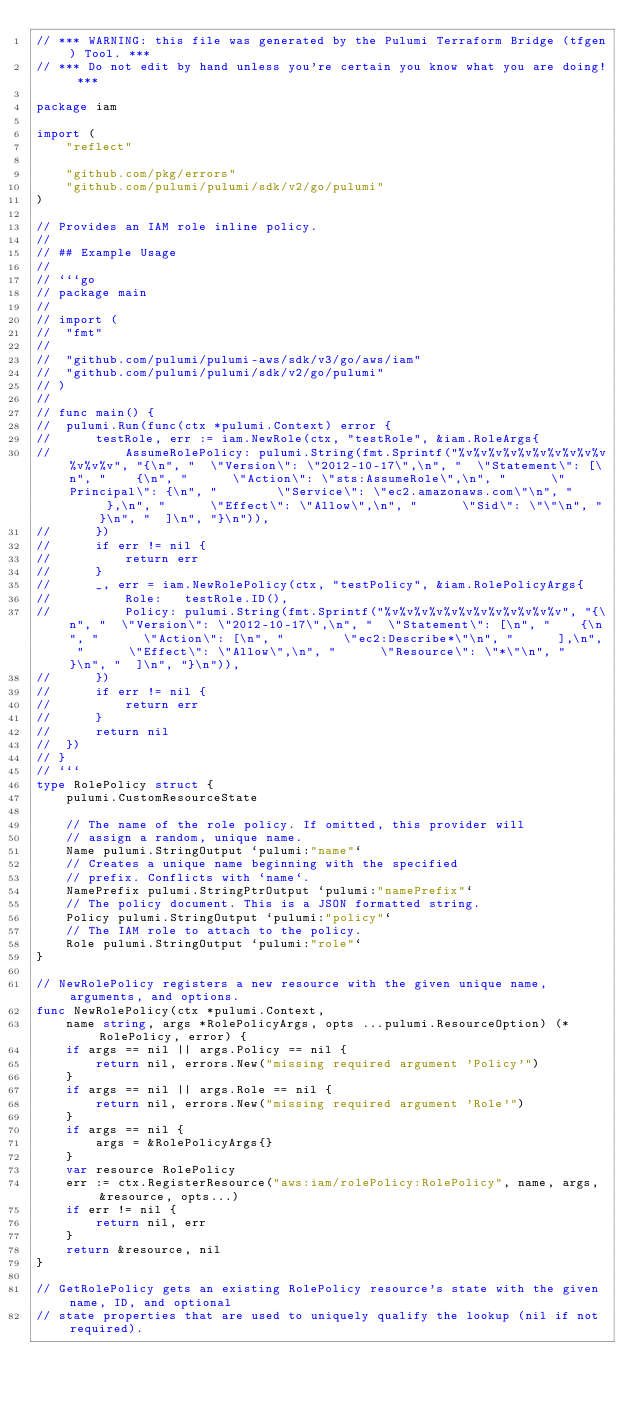Convert code to text. <code><loc_0><loc_0><loc_500><loc_500><_Go_>// *** WARNING: this file was generated by the Pulumi Terraform Bridge (tfgen) Tool. ***
// *** Do not edit by hand unless you're certain you know what you are doing! ***

package iam

import (
	"reflect"

	"github.com/pkg/errors"
	"github.com/pulumi/pulumi/sdk/v2/go/pulumi"
)

// Provides an IAM role inline policy.
//
// ## Example Usage
//
// ```go
// package main
//
// import (
// 	"fmt"
//
// 	"github.com/pulumi/pulumi-aws/sdk/v3/go/aws/iam"
// 	"github.com/pulumi/pulumi/sdk/v2/go/pulumi"
// )
//
// func main() {
// 	pulumi.Run(func(ctx *pulumi.Context) error {
// 		testRole, err := iam.NewRole(ctx, "testRole", &iam.RoleArgs{
// 			AssumeRolePolicy: pulumi.String(fmt.Sprintf("%v%v%v%v%v%v%v%v%v%v%v%v%v", "{\n", "  \"Version\": \"2012-10-17\",\n", "  \"Statement\": [\n", "    {\n", "      \"Action\": \"sts:AssumeRole\",\n", "      \"Principal\": {\n", "        \"Service\": \"ec2.amazonaws.com\"\n", "      },\n", "      \"Effect\": \"Allow\",\n", "      \"Sid\": \"\"\n", "    }\n", "  ]\n", "}\n")),
// 		})
// 		if err != nil {
// 			return err
// 		}
// 		_, err = iam.NewRolePolicy(ctx, "testPolicy", &iam.RolePolicyArgs{
// 			Role:   testRole.ID(),
// 			Policy: pulumi.String(fmt.Sprintf("%v%v%v%v%v%v%v%v%v%v%v%v", "{\n", "  \"Version\": \"2012-10-17\",\n", "  \"Statement\": [\n", "    {\n", "      \"Action\": [\n", "        \"ec2:Describe*\"\n", "      ],\n", "      \"Effect\": \"Allow\",\n", "      \"Resource\": \"*\"\n", "    }\n", "  ]\n", "}\n")),
// 		})
// 		if err != nil {
// 			return err
// 		}
// 		return nil
// 	})
// }
// ```
type RolePolicy struct {
	pulumi.CustomResourceState

	// The name of the role policy. If omitted, this provider will
	// assign a random, unique name.
	Name pulumi.StringOutput `pulumi:"name"`
	// Creates a unique name beginning with the specified
	// prefix. Conflicts with `name`.
	NamePrefix pulumi.StringPtrOutput `pulumi:"namePrefix"`
	// The policy document. This is a JSON formatted string.
	Policy pulumi.StringOutput `pulumi:"policy"`
	// The IAM role to attach to the policy.
	Role pulumi.StringOutput `pulumi:"role"`
}

// NewRolePolicy registers a new resource with the given unique name, arguments, and options.
func NewRolePolicy(ctx *pulumi.Context,
	name string, args *RolePolicyArgs, opts ...pulumi.ResourceOption) (*RolePolicy, error) {
	if args == nil || args.Policy == nil {
		return nil, errors.New("missing required argument 'Policy'")
	}
	if args == nil || args.Role == nil {
		return nil, errors.New("missing required argument 'Role'")
	}
	if args == nil {
		args = &RolePolicyArgs{}
	}
	var resource RolePolicy
	err := ctx.RegisterResource("aws:iam/rolePolicy:RolePolicy", name, args, &resource, opts...)
	if err != nil {
		return nil, err
	}
	return &resource, nil
}

// GetRolePolicy gets an existing RolePolicy resource's state with the given name, ID, and optional
// state properties that are used to uniquely qualify the lookup (nil if not required).</code> 